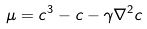<formula> <loc_0><loc_0><loc_500><loc_500>\mu = c ^ { 3 } - c - \gamma \nabla ^ { 2 } c</formula> 